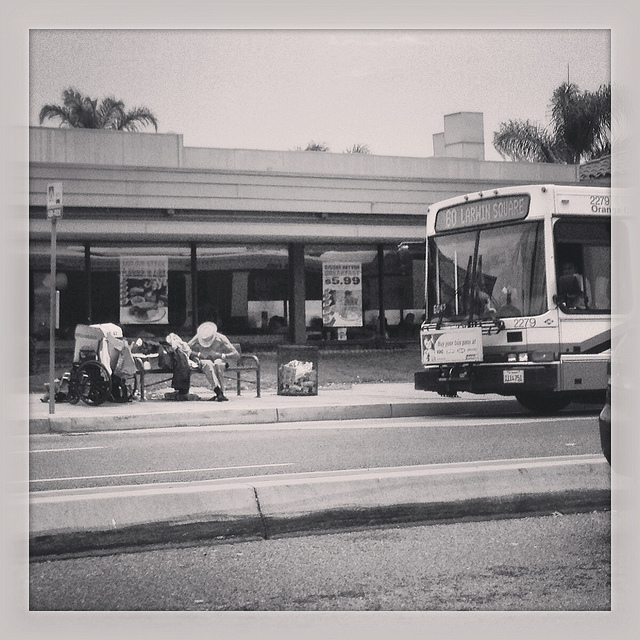<image>What is the phone number on the food truck at left? It is unknown what the phone number on the food truck is. There is no visible food truck to reference. What kind of soda is advertised over the door? There is no clear information about what kind of soda is advertised over the door. It could be 'Coke', 'Pepsi' or none. What is the phone number on the food truck at left? I am not sure what the phone number on the food truck at left is. There is no food truck in the image. What kind of soda is advertised over the door? The kind of soda advertised over the door is unknown. It can be seen 'coke', 'coca cola', 'pepsi', 'code' or 'no soda'. 